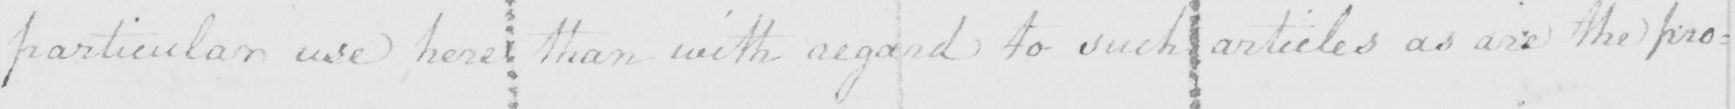What is written in this line of handwriting? particular use here than with regard to such articles as are the pro= 